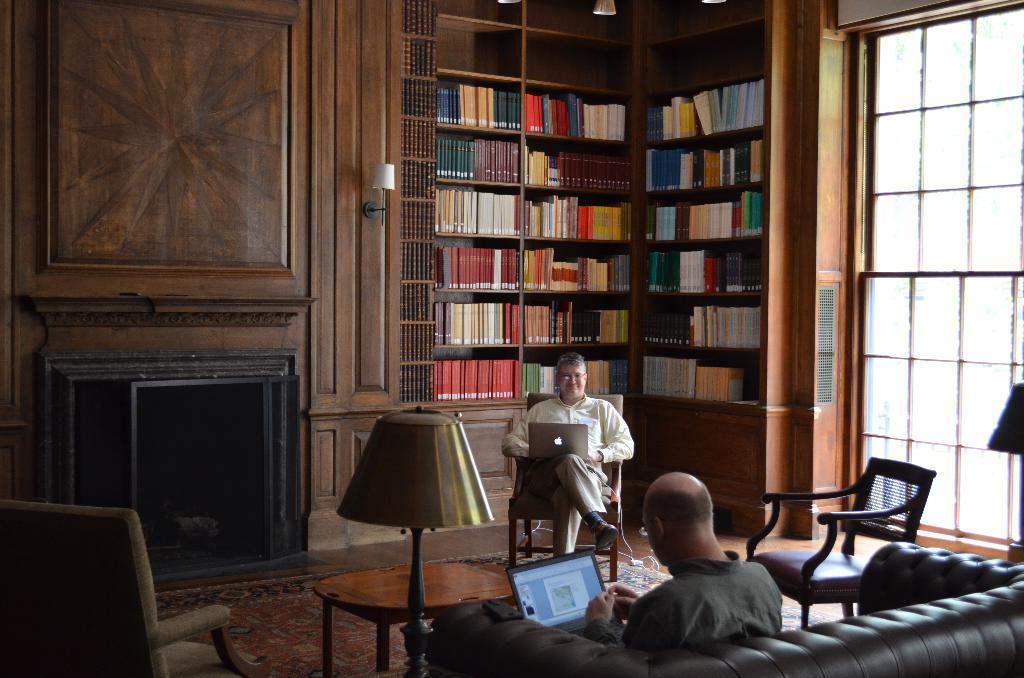How would you summarize this image in a sentence or two? At the bottom of the image we can see one chair, one lamp and one couch. On the couch, we can see one person is sitting and holding the laptop and he is wearing glasses. on the right side of the image, we can see one lamp. In the center of the image we can see one carpet, chairs, one table and one person is sitting on the chair and he is holding a laptop and he is also wearing glasses. In the background there is a wooden wall, glass, lamps, shelves, books and a few other objects. 